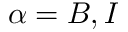Convert formula to latex. <formula><loc_0><loc_0><loc_500><loc_500>\alpha = B , I</formula> 